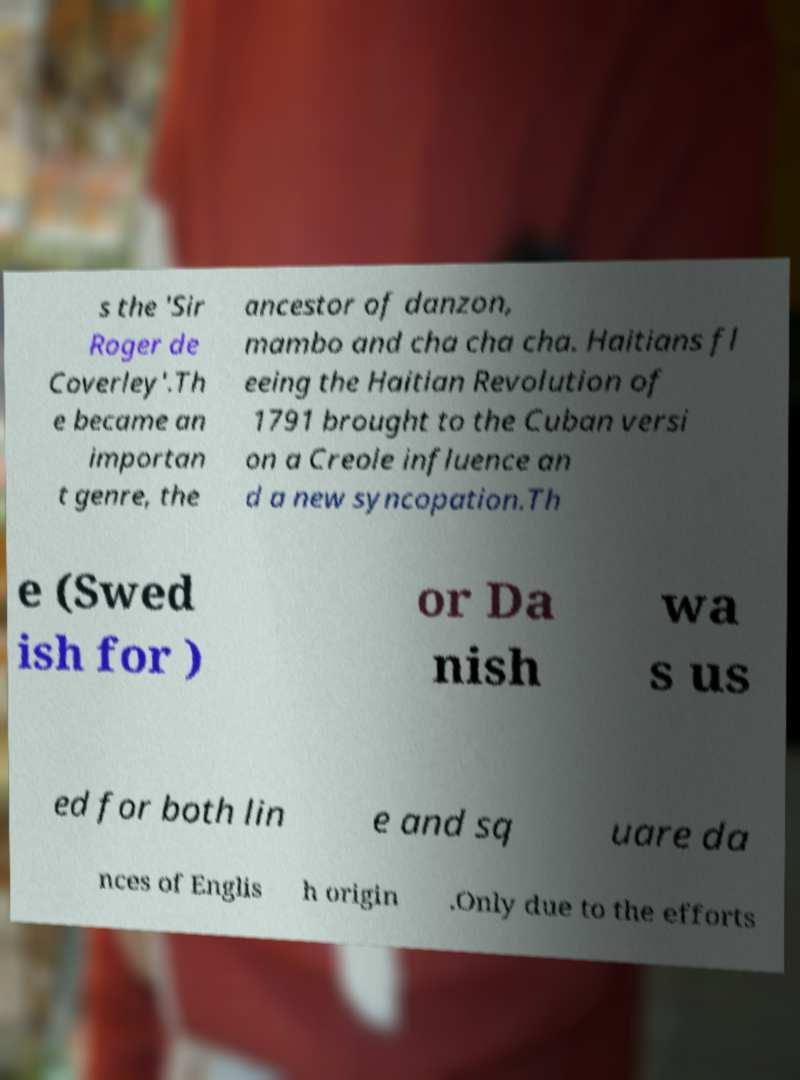There's text embedded in this image that I need extracted. Can you transcribe it verbatim? s the 'Sir Roger de Coverley'.Th e became an importan t genre, the ancestor of danzon, mambo and cha cha cha. Haitians fl eeing the Haitian Revolution of 1791 brought to the Cuban versi on a Creole influence an d a new syncopation.Th e (Swed ish for ) or Da nish wa s us ed for both lin e and sq uare da nces of Englis h origin .Only due to the efforts 